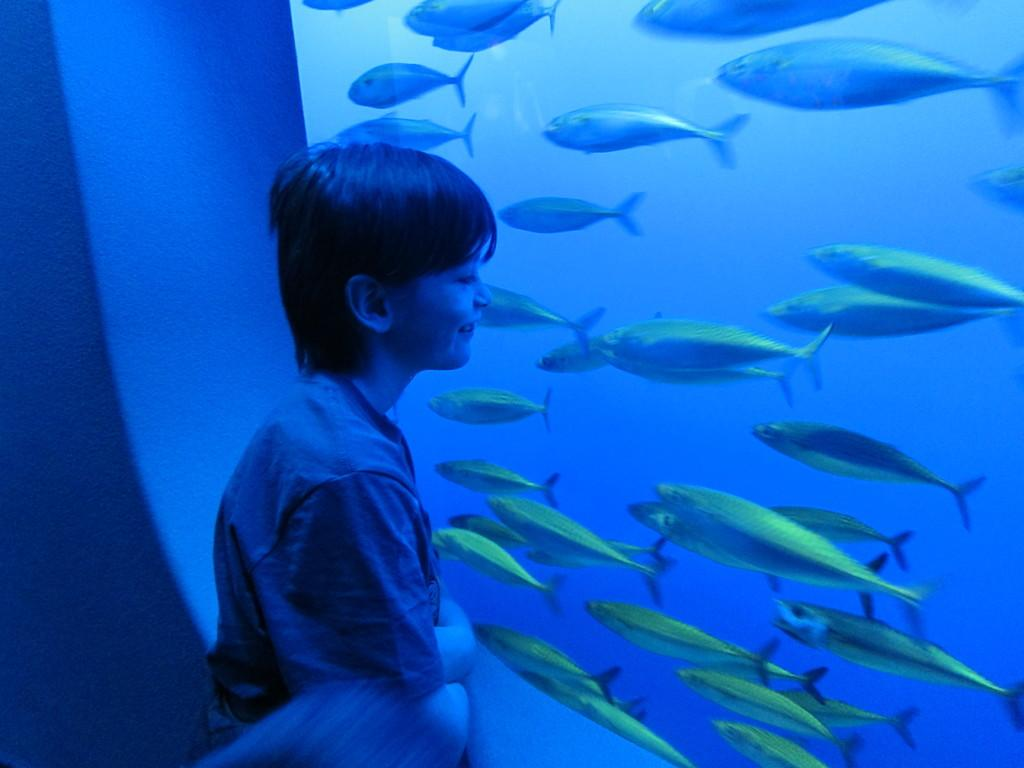What is located on the left side of the image? There is a boy on the left side of the image. What is the boy standing in front of? The boy is standing in front of an aquarium. What can be seen inside the aquarium? There are fish in the aquarium. What color is the background of the image? The background of the image is blue in color. What financial advice does the boy give in the image? There is no indication in the image that the boy is giving any financial advice. 